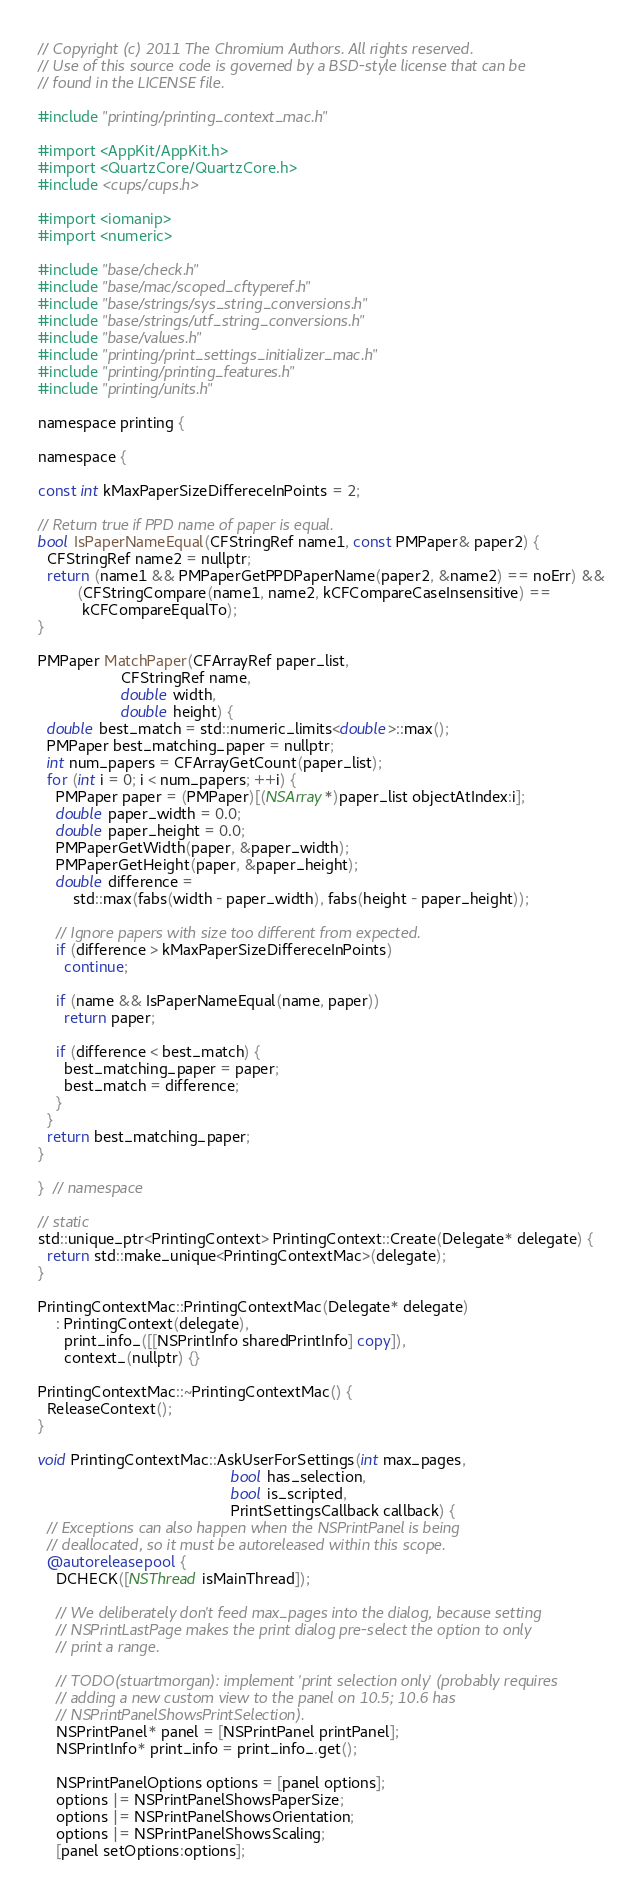Convert code to text. <code><loc_0><loc_0><loc_500><loc_500><_ObjectiveC_>// Copyright (c) 2011 The Chromium Authors. All rights reserved.
// Use of this source code is governed by a BSD-style license that can be
// found in the LICENSE file.

#include "printing/printing_context_mac.h"

#import <AppKit/AppKit.h>
#import <QuartzCore/QuartzCore.h>
#include <cups/cups.h>

#import <iomanip>
#import <numeric>

#include "base/check.h"
#include "base/mac/scoped_cftyperef.h"
#include "base/strings/sys_string_conversions.h"
#include "base/strings/utf_string_conversions.h"
#include "base/values.h"
#include "printing/print_settings_initializer_mac.h"
#include "printing/printing_features.h"
#include "printing/units.h"

namespace printing {

namespace {

const int kMaxPaperSizeDiffereceInPoints = 2;

// Return true if PPD name of paper is equal.
bool IsPaperNameEqual(CFStringRef name1, const PMPaper& paper2) {
  CFStringRef name2 = nullptr;
  return (name1 && PMPaperGetPPDPaperName(paper2, &name2) == noErr) &&
         (CFStringCompare(name1, name2, kCFCompareCaseInsensitive) ==
          kCFCompareEqualTo);
}

PMPaper MatchPaper(CFArrayRef paper_list,
                   CFStringRef name,
                   double width,
                   double height) {
  double best_match = std::numeric_limits<double>::max();
  PMPaper best_matching_paper = nullptr;
  int num_papers = CFArrayGetCount(paper_list);
  for (int i = 0; i < num_papers; ++i) {
    PMPaper paper = (PMPaper)[(NSArray*)paper_list objectAtIndex:i];
    double paper_width = 0.0;
    double paper_height = 0.0;
    PMPaperGetWidth(paper, &paper_width);
    PMPaperGetHeight(paper, &paper_height);
    double difference =
        std::max(fabs(width - paper_width), fabs(height - paper_height));

    // Ignore papers with size too different from expected.
    if (difference > kMaxPaperSizeDiffereceInPoints)
      continue;

    if (name && IsPaperNameEqual(name, paper))
      return paper;

    if (difference < best_match) {
      best_matching_paper = paper;
      best_match = difference;
    }
  }
  return best_matching_paper;
}

}  // namespace

// static
std::unique_ptr<PrintingContext> PrintingContext::Create(Delegate* delegate) {
  return std::make_unique<PrintingContextMac>(delegate);
}

PrintingContextMac::PrintingContextMac(Delegate* delegate)
    : PrintingContext(delegate),
      print_info_([[NSPrintInfo sharedPrintInfo] copy]),
      context_(nullptr) {}

PrintingContextMac::~PrintingContextMac() {
  ReleaseContext();
}

void PrintingContextMac::AskUserForSettings(int max_pages,
                                            bool has_selection,
                                            bool is_scripted,
                                            PrintSettingsCallback callback) {
  // Exceptions can also happen when the NSPrintPanel is being
  // deallocated, so it must be autoreleased within this scope.
  @autoreleasepool {
    DCHECK([NSThread isMainThread]);

    // We deliberately don't feed max_pages into the dialog, because setting
    // NSPrintLastPage makes the print dialog pre-select the option to only
    // print a range.

    // TODO(stuartmorgan): implement 'print selection only' (probably requires
    // adding a new custom view to the panel on 10.5; 10.6 has
    // NSPrintPanelShowsPrintSelection).
    NSPrintPanel* panel = [NSPrintPanel printPanel];
    NSPrintInfo* print_info = print_info_.get();

    NSPrintPanelOptions options = [panel options];
    options |= NSPrintPanelShowsPaperSize;
    options |= NSPrintPanelShowsOrientation;
    options |= NSPrintPanelShowsScaling;
    [panel setOptions:options];
</code> 